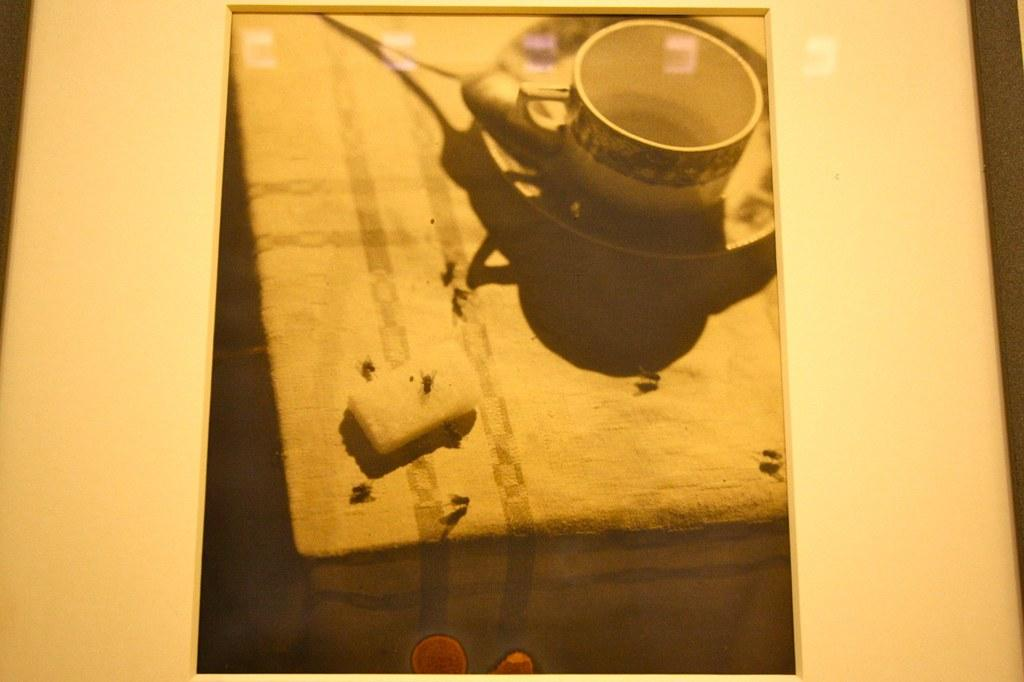What object in the image has white borders? There is a photo frame in the image with white borders. What is depicted in the photo frame? There is a photo of a cup and saucer in the frame. Are there any insects visible in the image? Yes, there are flies visible in the image. How many prisoners are visible in the image? There are no prisoners present in the image. What type of food is being served in the pizzas shown in the image? There are no pizzas present in the image. 